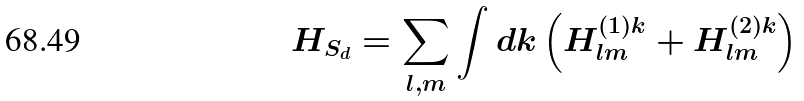Convert formula to latex. <formula><loc_0><loc_0><loc_500><loc_500>H _ { S _ { d } } = \sum _ { l , m } \int d { k } \left ( H ^ { ( 1 ) { k } } _ { l m } + H ^ { ( 2 ) { k } } _ { l m } \right )</formula> 